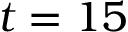Convert formula to latex. <formula><loc_0><loc_0><loc_500><loc_500>t = 1 5</formula> 